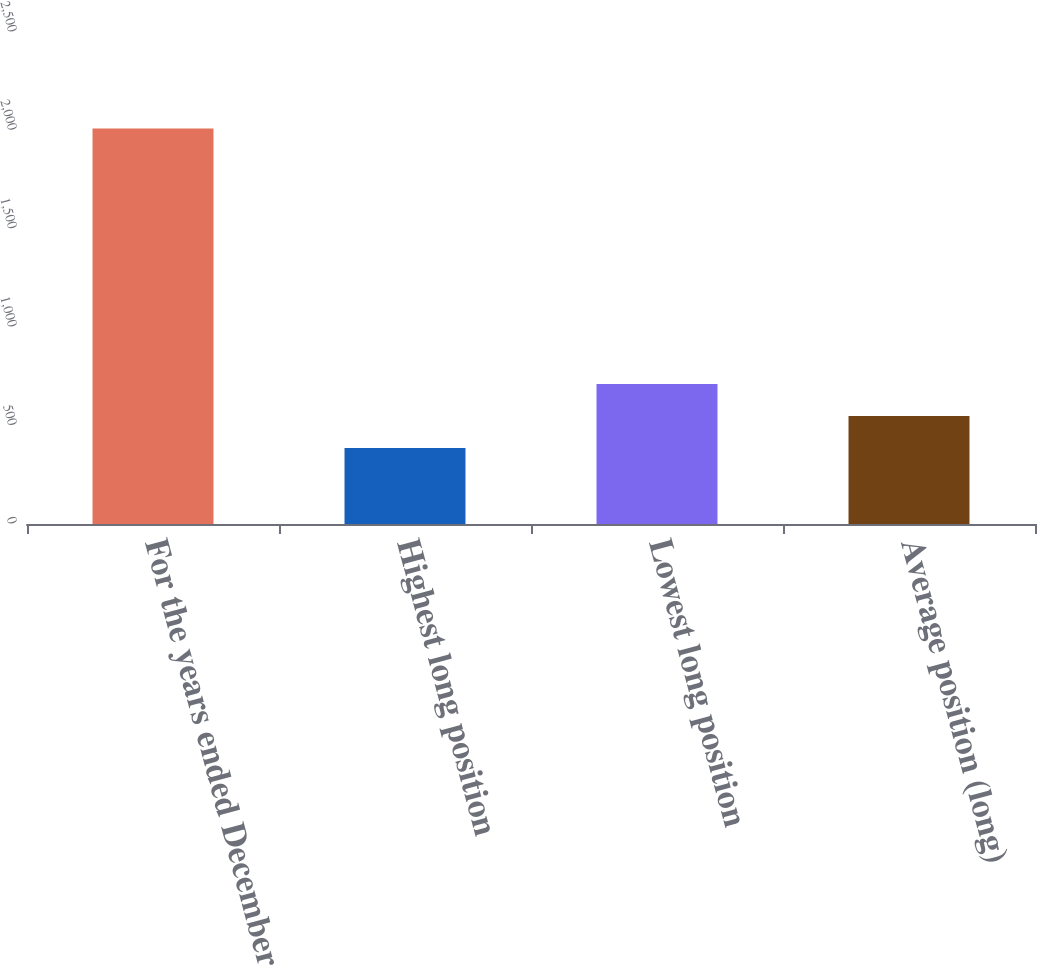<chart> <loc_0><loc_0><loc_500><loc_500><bar_chart><fcel>For the years ended December<fcel>Highest long position<fcel>Lowest long position<fcel>Average position (long)<nl><fcel>2010<fcel>386.2<fcel>710.96<fcel>548.58<nl></chart> 